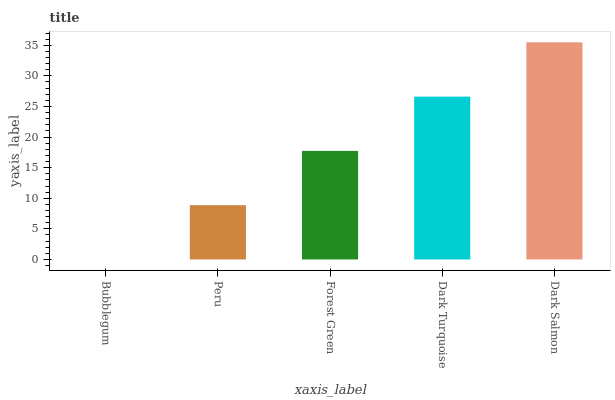Is Bubblegum the minimum?
Answer yes or no. Yes. Is Dark Salmon the maximum?
Answer yes or no. Yes. Is Peru the minimum?
Answer yes or no. No. Is Peru the maximum?
Answer yes or no. No. Is Peru greater than Bubblegum?
Answer yes or no. Yes. Is Bubblegum less than Peru?
Answer yes or no. Yes. Is Bubblegum greater than Peru?
Answer yes or no. No. Is Peru less than Bubblegum?
Answer yes or no. No. Is Forest Green the high median?
Answer yes or no. Yes. Is Forest Green the low median?
Answer yes or no. Yes. Is Dark Salmon the high median?
Answer yes or no. No. Is Peru the low median?
Answer yes or no. No. 